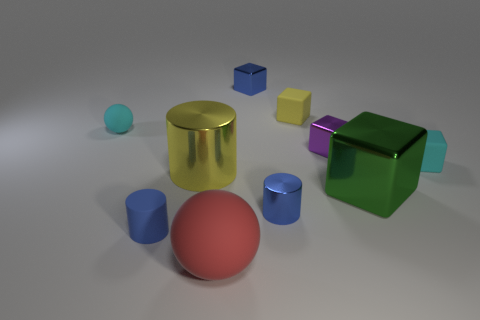There is a small object that is the same color as the big cylinder; what material is it?
Your answer should be very brief. Rubber. There is a metallic cube that is the same color as the matte cylinder; what size is it?
Offer a terse response. Small. What number of other objects are there of the same shape as the big green shiny thing?
Your response must be concise. 4. Is the number of blue shiny cylinders greater than the number of cyan objects?
Ensure brevity in your answer.  No. What shape is the small blue metallic thing in front of the big shiny object to the right of the metallic object left of the red rubber object?
Your answer should be very brief. Cylinder. Do the tiny thing that is on the left side of the rubber cylinder and the blue object that is behind the large metallic block have the same material?
Keep it short and to the point. No. What is the shape of the cyan object that is the same material as the cyan cube?
Give a very brief answer. Sphere. Is there any other thing that has the same color as the big metallic cylinder?
Your answer should be compact. Yes. How many large blue rubber cylinders are there?
Ensure brevity in your answer.  0. The small blue thing that is behind the small rubber block right of the green object is made of what material?
Keep it short and to the point. Metal. 